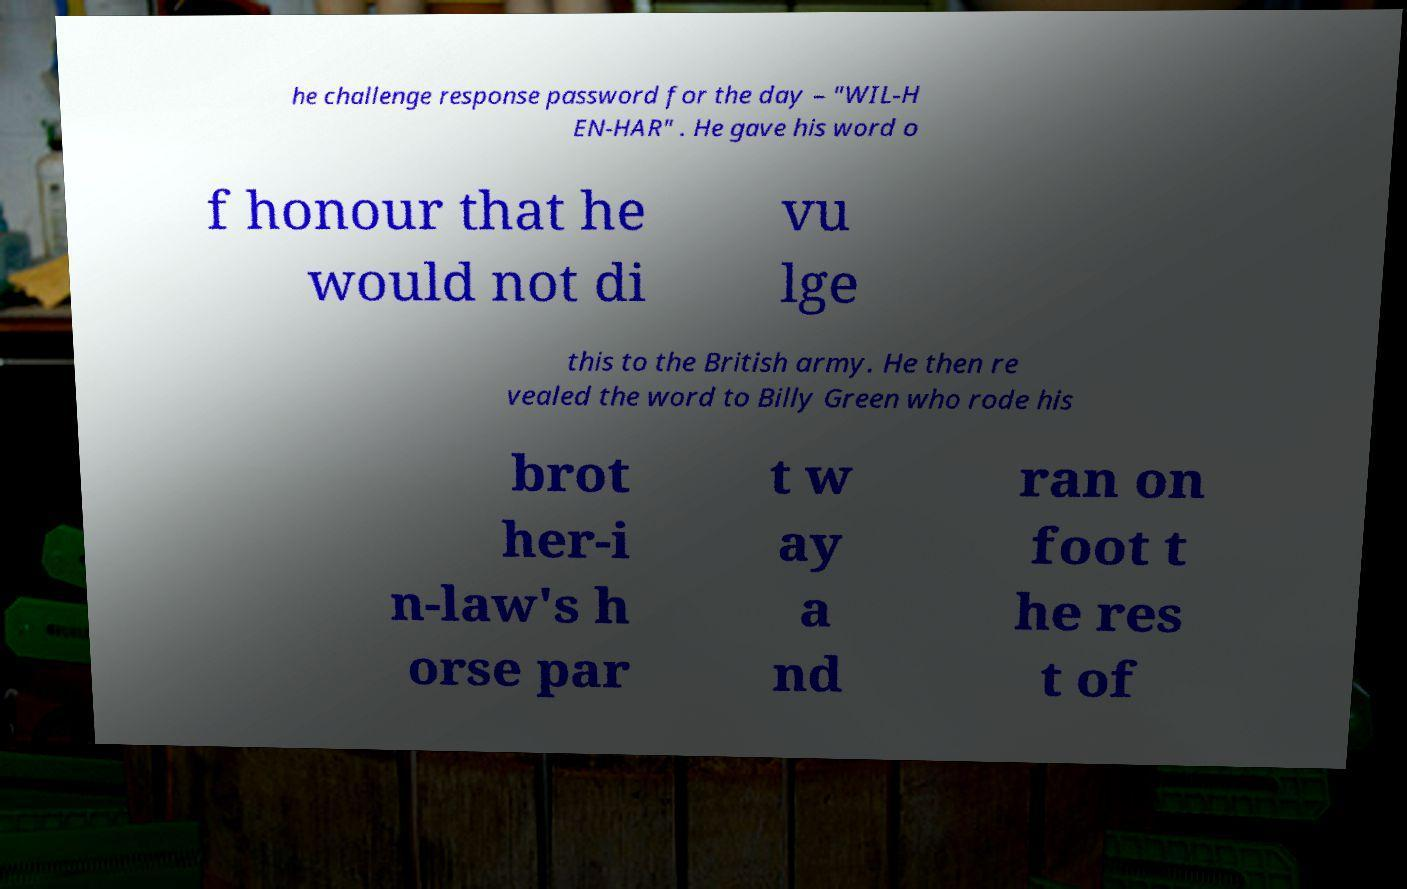I need the written content from this picture converted into text. Can you do that? he challenge response password for the day – "WIL-H EN-HAR" . He gave his word o f honour that he would not di vu lge this to the British army. He then re vealed the word to Billy Green who rode his brot her-i n-law's h orse par t w ay a nd ran on foot t he res t of 